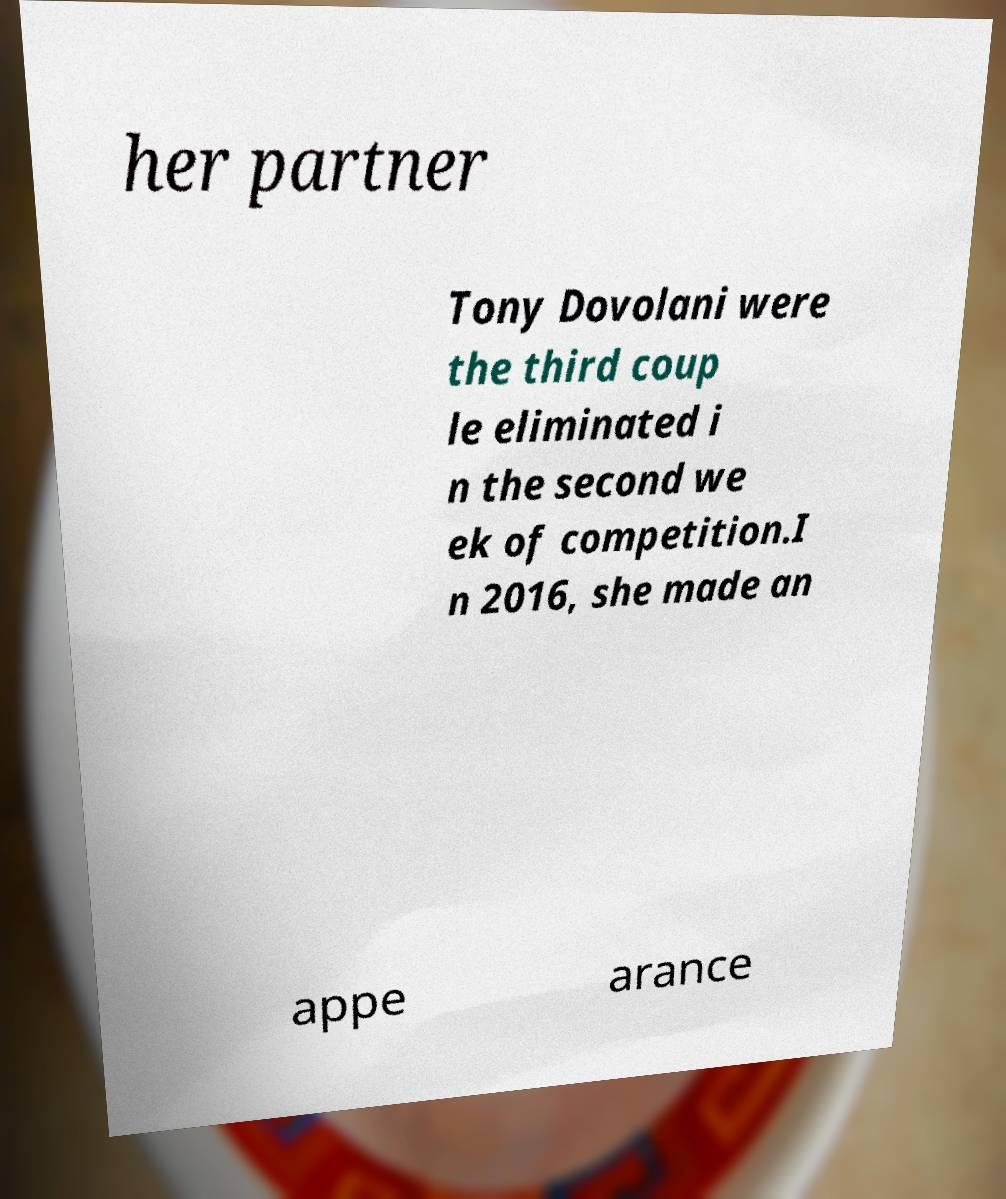Could you extract and type out the text from this image? her partner Tony Dovolani were the third coup le eliminated i n the second we ek of competition.I n 2016, she made an appe arance 